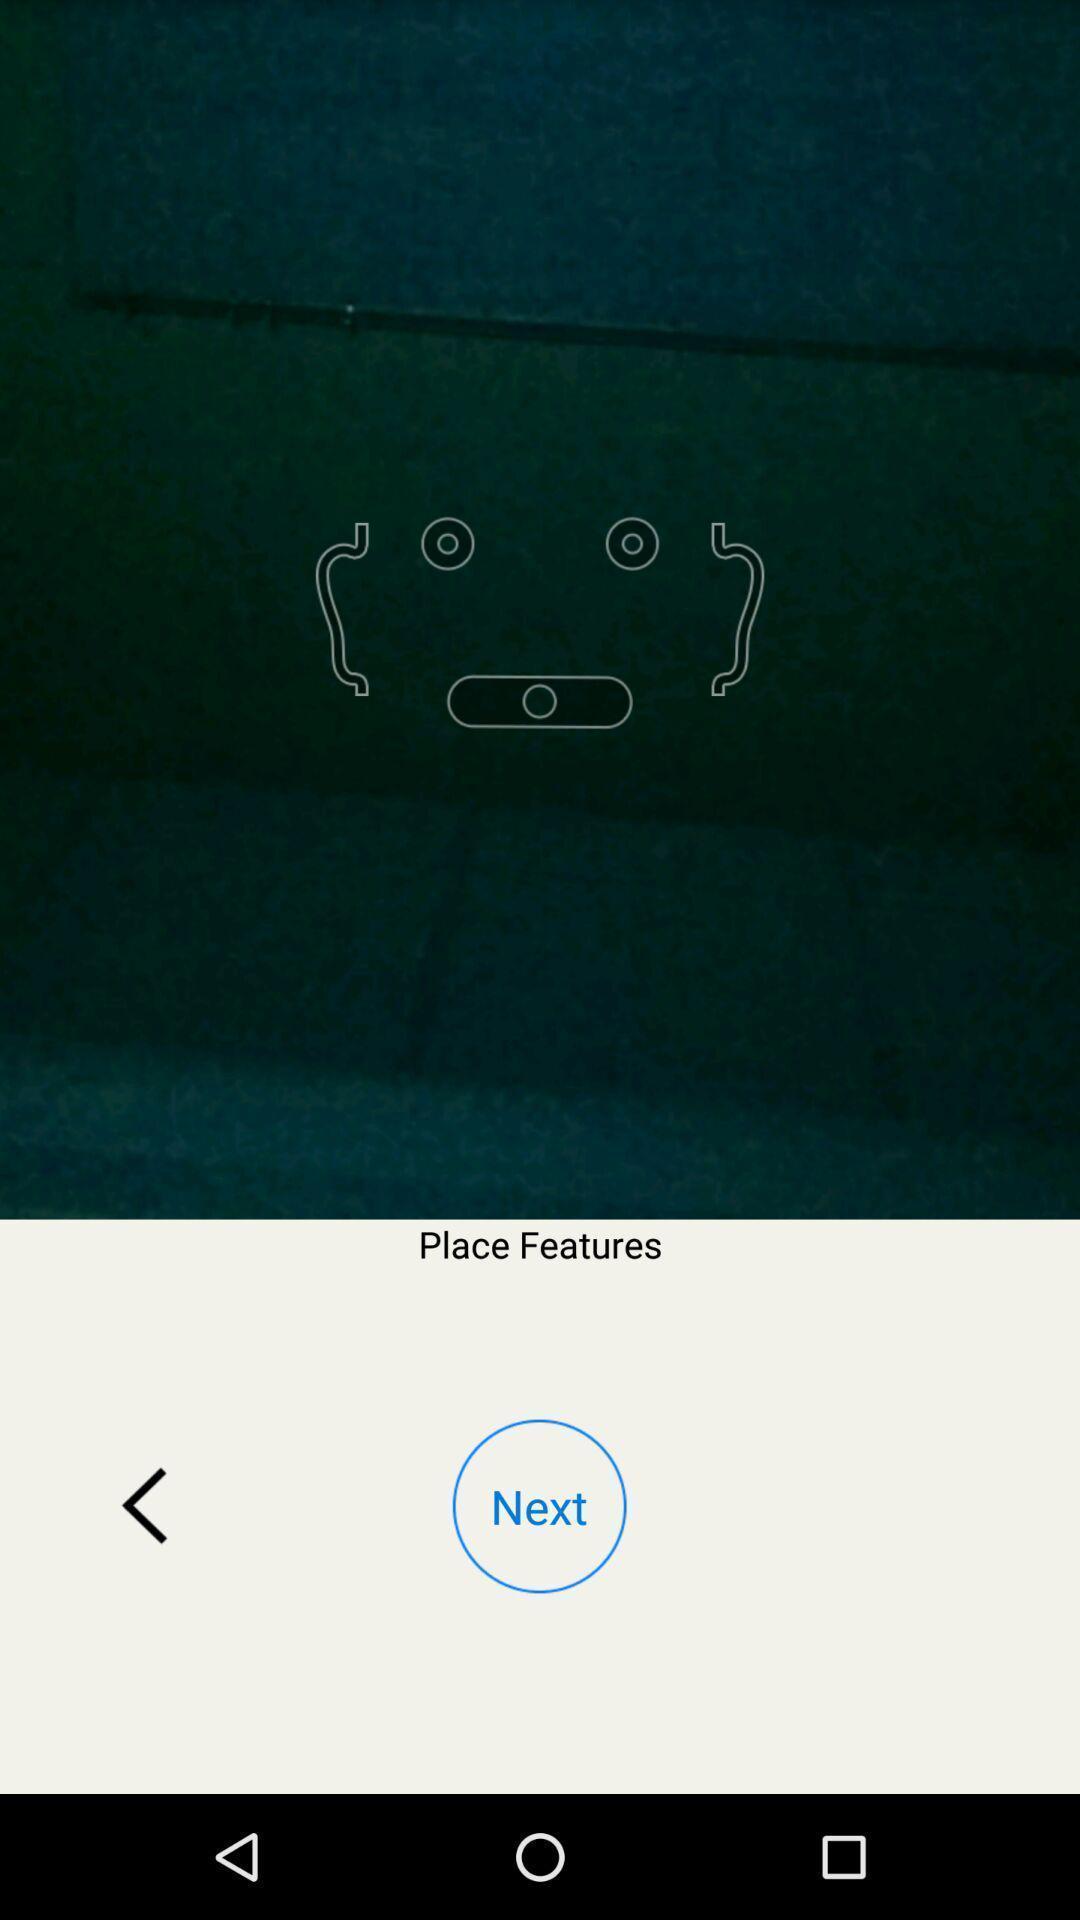Tell me what you see in this picture. Pop up showing next option. 